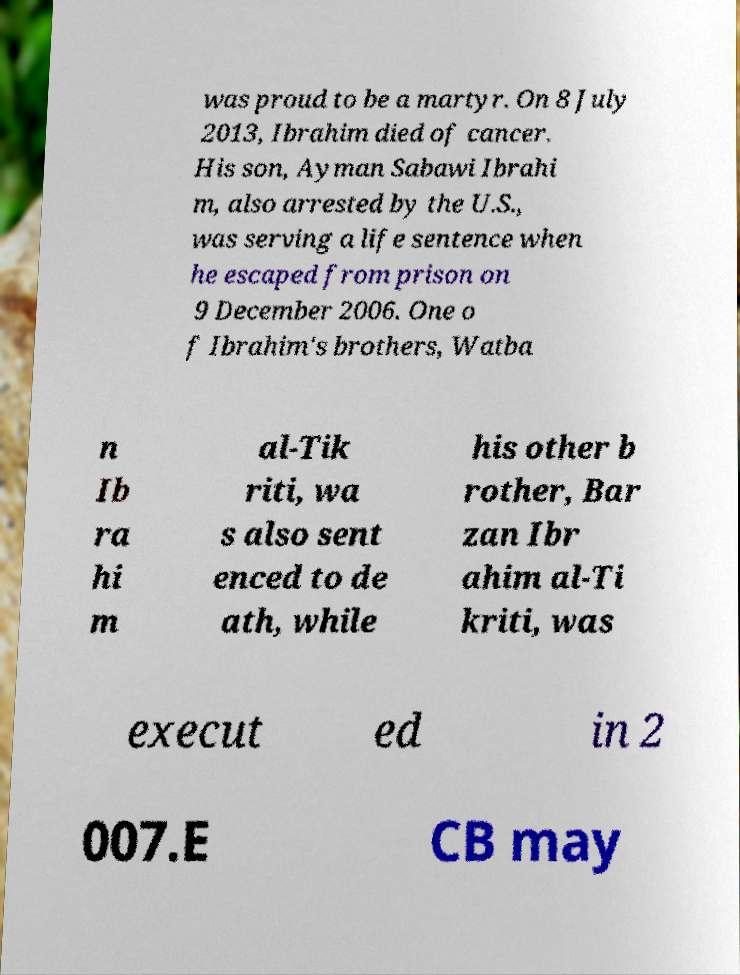Could you assist in decoding the text presented in this image and type it out clearly? was proud to be a martyr. On 8 July 2013, Ibrahim died of cancer. His son, Ayman Sabawi Ibrahi m, also arrested by the U.S., was serving a life sentence when he escaped from prison on 9 December 2006. One o f Ibrahim's brothers, Watba n Ib ra hi m al-Tik riti, wa s also sent enced to de ath, while his other b rother, Bar zan Ibr ahim al-Ti kriti, was execut ed in 2 007.E CB may 